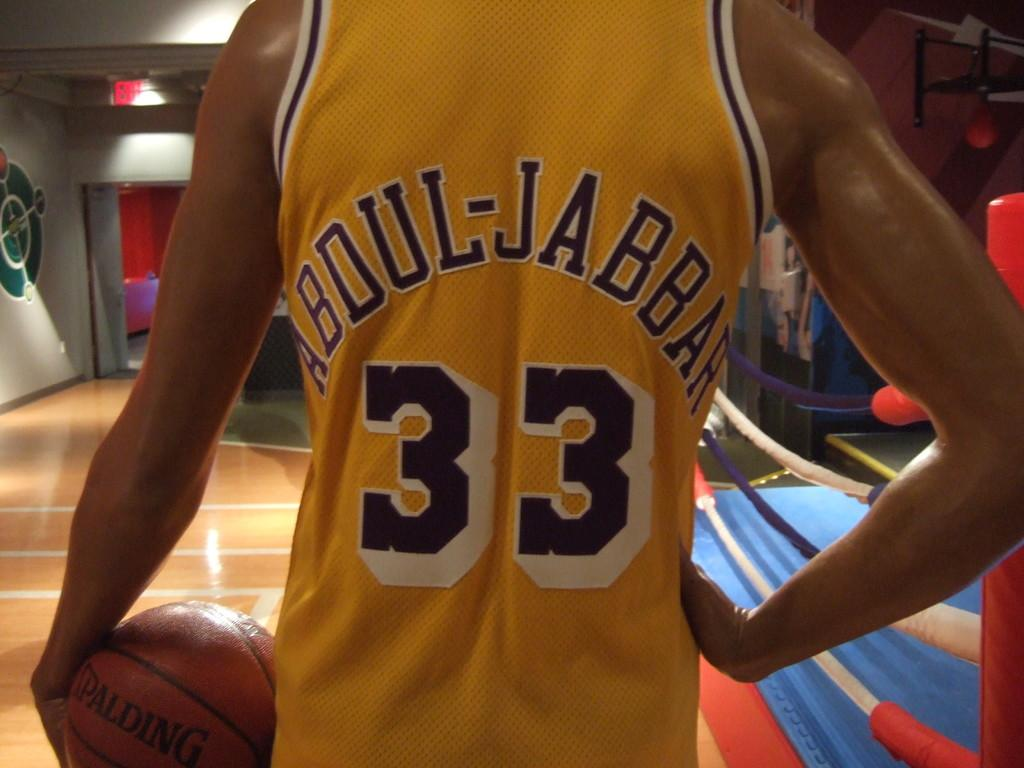<image>
Share a concise interpretation of the image provided. A basketball member wearing a yellow jersey that says Abdul-Jabbar 33 on the back standing with a basketball in his left hand and his right hand on his hip. 